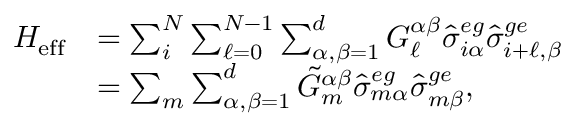Convert formula to latex. <formula><loc_0><loc_0><loc_500><loc_500>\begin{array} { r l } { H _ { e f f } } & { = \sum _ { i } ^ { N } \sum _ { \ell = 0 } ^ { N - 1 } \sum _ { \alpha , \beta = 1 } ^ { d } G _ { \ell } ^ { \alpha \beta } \hat { \sigma } _ { i \alpha } ^ { e g } \hat { \sigma } _ { i + \ell , \beta } ^ { g e } } \\ & { = \sum _ { m } \sum _ { \alpha , \beta = 1 } ^ { d } \tilde { G } _ { m } ^ { \alpha \beta } \hat { \sigma } _ { m \alpha } ^ { e g } \hat { \sigma } _ { m \beta } ^ { g e } , } \end{array}</formula> 